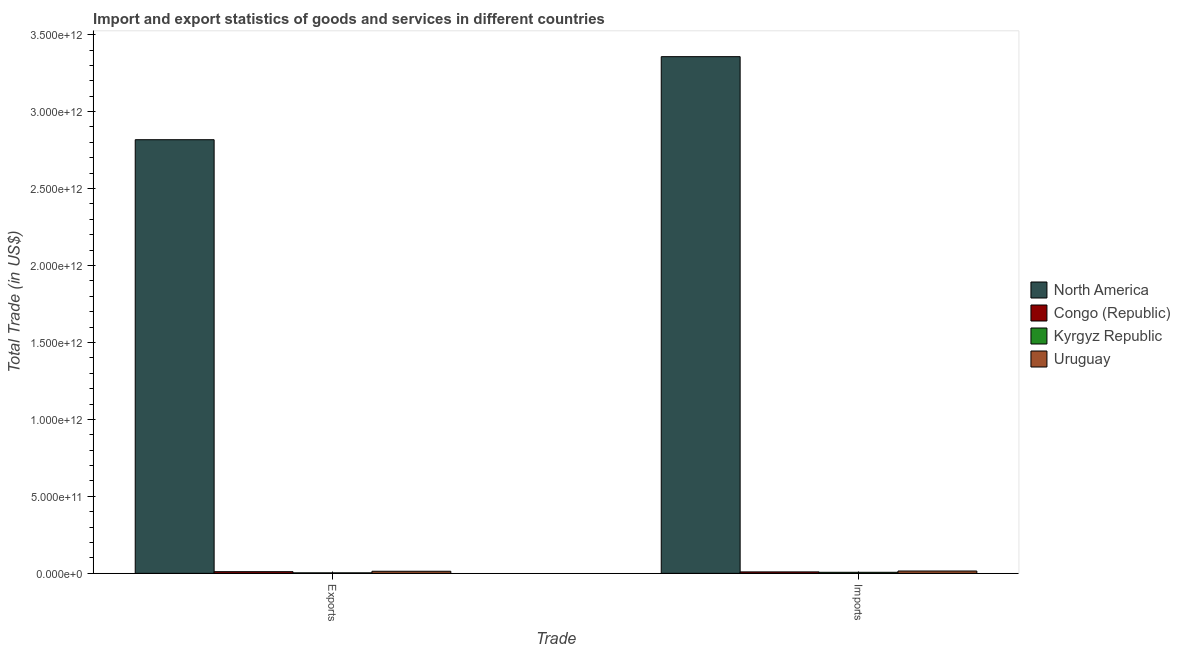How many groups of bars are there?
Your answer should be compact. 2. How many bars are there on the 1st tick from the left?
Make the answer very short. 4. How many bars are there on the 1st tick from the right?
Provide a short and direct response. 4. What is the label of the 1st group of bars from the left?
Keep it short and to the point. Exports. What is the imports of goods and services in North America?
Ensure brevity in your answer.  3.36e+12. Across all countries, what is the maximum export of goods and services?
Give a very brief answer. 2.82e+12. Across all countries, what is the minimum imports of goods and services?
Offer a very short reply. 6.73e+09. In which country was the imports of goods and services maximum?
Offer a very short reply. North America. In which country was the imports of goods and services minimum?
Provide a succinct answer. Kyrgyz Republic. What is the total export of goods and services in the graph?
Your answer should be very brief. 2.84e+12. What is the difference between the imports of goods and services in Congo (Republic) and that in Kyrgyz Republic?
Make the answer very short. 2.57e+09. What is the difference between the imports of goods and services in Uruguay and the export of goods and services in Kyrgyz Republic?
Offer a very short reply. 1.20e+1. What is the average export of goods and services per country?
Provide a succinct answer. 7.11e+11. What is the difference between the export of goods and services and imports of goods and services in North America?
Provide a short and direct response. -5.40e+11. In how many countries, is the export of goods and services greater than 1600000000000 US$?
Your answer should be very brief. 1. What is the ratio of the export of goods and services in North America to that in Uruguay?
Offer a terse response. 208.6. Is the export of goods and services in Kyrgyz Republic less than that in Congo (Republic)?
Make the answer very short. Yes. What does the 2nd bar from the left in Imports represents?
Provide a short and direct response. Congo (Republic). What does the 2nd bar from the right in Imports represents?
Keep it short and to the point. Kyrgyz Republic. How many countries are there in the graph?
Provide a succinct answer. 4. What is the difference between two consecutive major ticks on the Y-axis?
Offer a very short reply. 5.00e+11. Are the values on the major ticks of Y-axis written in scientific E-notation?
Keep it short and to the point. Yes. Does the graph contain grids?
Your answer should be very brief. No. Where does the legend appear in the graph?
Make the answer very short. Center right. How are the legend labels stacked?
Ensure brevity in your answer.  Vertical. What is the title of the graph?
Offer a terse response. Import and export statistics of goods and services in different countries. Does "Kyrgyz Republic" appear as one of the legend labels in the graph?
Provide a succinct answer. Yes. What is the label or title of the X-axis?
Offer a terse response. Trade. What is the label or title of the Y-axis?
Offer a terse response. Total Trade (in US$). What is the Total Trade (in US$) of North America in Exports?
Your answer should be compact. 2.82e+12. What is the Total Trade (in US$) of Congo (Republic) in Exports?
Provide a succinct answer. 1.08e+1. What is the Total Trade (in US$) in Kyrgyz Republic in Exports?
Give a very brief answer. 3.10e+09. What is the Total Trade (in US$) of Uruguay in Exports?
Provide a short and direct response. 1.35e+1. What is the Total Trade (in US$) in North America in Imports?
Your response must be concise. 3.36e+12. What is the Total Trade (in US$) of Congo (Republic) in Imports?
Make the answer very short. 9.31e+09. What is the Total Trade (in US$) of Kyrgyz Republic in Imports?
Your answer should be compact. 6.73e+09. What is the Total Trade (in US$) of Uruguay in Imports?
Provide a succinct answer. 1.51e+1. Across all Trade, what is the maximum Total Trade (in US$) in North America?
Ensure brevity in your answer.  3.36e+12. Across all Trade, what is the maximum Total Trade (in US$) in Congo (Republic)?
Offer a terse response. 1.08e+1. Across all Trade, what is the maximum Total Trade (in US$) in Kyrgyz Republic?
Provide a succinct answer. 6.73e+09. Across all Trade, what is the maximum Total Trade (in US$) of Uruguay?
Your response must be concise. 1.51e+1. Across all Trade, what is the minimum Total Trade (in US$) of North America?
Keep it short and to the point. 2.82e+12. Across all Trade, what is the minimum Total Trade (in US$) of Congo (Republic)?
Make the answer very short. 9.31e+09. Across all Trade, what is the minimum Total Trade (in US$) in Kyrgyz Republic?
Keep it short and to the point. 3.10e+09. Across all Trade, what is the minimum Total Trade (in US$) in Uruguay?
Provide a succinct answer. 1.35e+1. What is the total Total Trade (in US$) in North America in the graph?
Offer a terse response. 6.17e+12. What is the total Total Trade (in US$) of Congo (Republic) in the graph?
Offer a terse response. 2.01e+1. What is the total Total Trade (in US$) in Kyrgyz Republic in the graph?
Give a very brief answer. 9.83e+09. What is the total Total Trade (in US$) of Uruguay in the graph?
Your answer should be compact. 2.86e+1. What is the difference between the Total Trade (in US$) of North America in Exports and that in Imports?
Your answer should be very brief. -5.40e+11. What is the difference between the Total Trade (in US$) in Congo (Republic) in Exports and that in Imports?
Keep it short and to the point. 1.47e+09. What is the difference between the Total Trade (in US$) of Kyrgyz Republic in Exports and that in Imports?
Keep it short and to the point. -3.63e+09. What is the difference between the Total Trade (in US$) of Uruguay in Exports and that in Imports?
Make the answer very short. -1.58e+09. What is the difference between the Total Trade (in US$) of North America in Exports and the Total Trade (in US$) of Congo (Republic) in Imports?
Offer a terse response. 2.81e+12. What is the difference between the Total Trade (in US$) in North America in Exports and the Total Trade (in US$) in Kyrgyz Republic in Imports?
Offer a very short reply. 2.81e+12. What is the difference between the Total Trade (in US$) in North America in Exports and the Total Trade (in US$) in Uruguay in Imports?
Provide a succinct answer. 2.80e+12. What is the difference between the Total Trade (in US$) of Congo (Republic) in Exports and the Total Trade (in US$) of Kyrgyz Republic in Imports?
Ensure brevity in your answer.  4.05e+09. What is the difference between the Total Trade (in US$) of Congo (Republic) in Exports and the Total Trade (in US$) of Uruguay in Imports?
Your answer should be compact. -4.31e+09. What is the difference between the Total Trade (in US$) of Kyrgyz Republic in Exports and the Total Trade (in US$) of Uruguay in Imports?
Offer a very short reply. -1.20e+1. What is the average Total Trade (in US$) of North America per Trade?
Your answer should be very brief. 3.09e+12. What is the average Total Trade (in US$) in Congo (Republic) per Trade?
Provide a short and direct response. 1.00e+1. What is the average Total Trade (in US$) in Kyrgyz Republic per Trade?
Ensure brevity in your answer.  4.92e+09. What is the average Total Trade (in US$) of Uruguay per Trade?
Make the answer very short. 1.43e+1. What is the difference between the Total Trade (in US$) of North America and Total Trade (in US$) of Congo (Republic) in Exports?
Provide a short and direct response. 2.81e+12. What is the difference between the Total Trade (in US$) in North America and Total Trade (in US$) in Kyrgyz Republic in Exports?
Keep it short and to the point. 2.81e+12. What is the difference between the Total Trade (in US$) in North America and Total Trade (in US$) in Uruguay in Exports?
Ensure brevity in your answer.  2.80e+12. What is the difference between the Total Trade (in US$) of Congo (Republic) and Total Trade (in US$) of Kyrgyz Republic in Exports?
Make the answer very short. 7.68e+09. What is the difference between the Total Trade (in US$) in Congo (Republic) and Total Trade (in US$) in Uruguay in Exports?
Provide a short and direct response. -2.73e+09. What is the difference between the Total Trade (in US$) of Kyrgyz Republic and Total Trade (in US$) of Uruguay in Exports?
Give a very brief answer. -1.04e+1. What is the difference between the Total Trade (in US$) in North America and Total Trade (in US$) in Congo (Republic) in Imports?
Provide a short and direct response. 3.35e+12. What is the difference between the Total Trade (in US$) in North America and Total Trade (in US$) in Kyrgyz Republic in Imports?
Offer a terse response. 3.35e+12. What is the difference between the Total Trade (in US$) in North America and Total Trade (in US$) in Uruguay in Imports?
Offer a terse response. 3.34e+12. What is the difference between the Total Trade (in US$) of Congo (Republic) and Total Trade (in US$) of Kyrgyz Republic in Imports?
Your response must be concise. 2.57e+09. What is the difference between the Total Trade (in US$) of Congo (Republic) and Total Trade (in US$) of Uruguay in Imports?
Offer a very short reply. -5.78e+09. What is the difference between the Total Trade (in US$) of Kyrgyz Republic and Total Trade (in US$) of Uruguay in Imports?
Offer a terse response. -8.36e+09. What is the ratio of the Total Trade (in US$) of North America in Exports to that in Imports?
Your answer should be compact. 0.84. What is the ratio of the Total Trade (in US$) in Congo (Republic) in Exports to that in Imports?
Offer a very short reply. 1.16. What is the ratio of the Total Trade (in US$) of Kyrgyz Republic in Exports to that in Imports?
Keep it short and to the point. 0.46. What is the ratio of the Total Trade (in US$) in Uruguay in Exports to that in Imports?
Keep it short and to the point. 0.9. What is the difference between the highest and the second highest Total Trade (in US$) of North America?
Your response must be concise. 5.40e+11. What is the difference between the highest and the second highest Total Trade (in US$) in Congo (Republic)?
Provide a short and direct response. 1.47e+09. What is the difference between the highest and the second highest Total Trade (in US$) of Kyrgyz Republic?
Provide a succinct answer. 3.63e+09. What is the difference between the highest and the second highest Total Trade (in US$) of Uruguay?
Make the answer very short. 1.58e+09. What is the difference between the highest and the lowest Total Trade (in US$) of North America?
Your answer should be very brief. 5.40e+11. What is the difference between the highest and the lowest Total Trade (in US$) of Congo (Republic)?
Offer a terse response. 1.47e+09. What is the difference between the highest and the lowest Total Trade (in US$) in Kyrgyz Republic?
Give a very brief answer. 3.63e+09. What is the difference between the highest and the lowest Total Trade (in US$) in Uruguay?
Provide a short and direct response. 1.58e+09. 